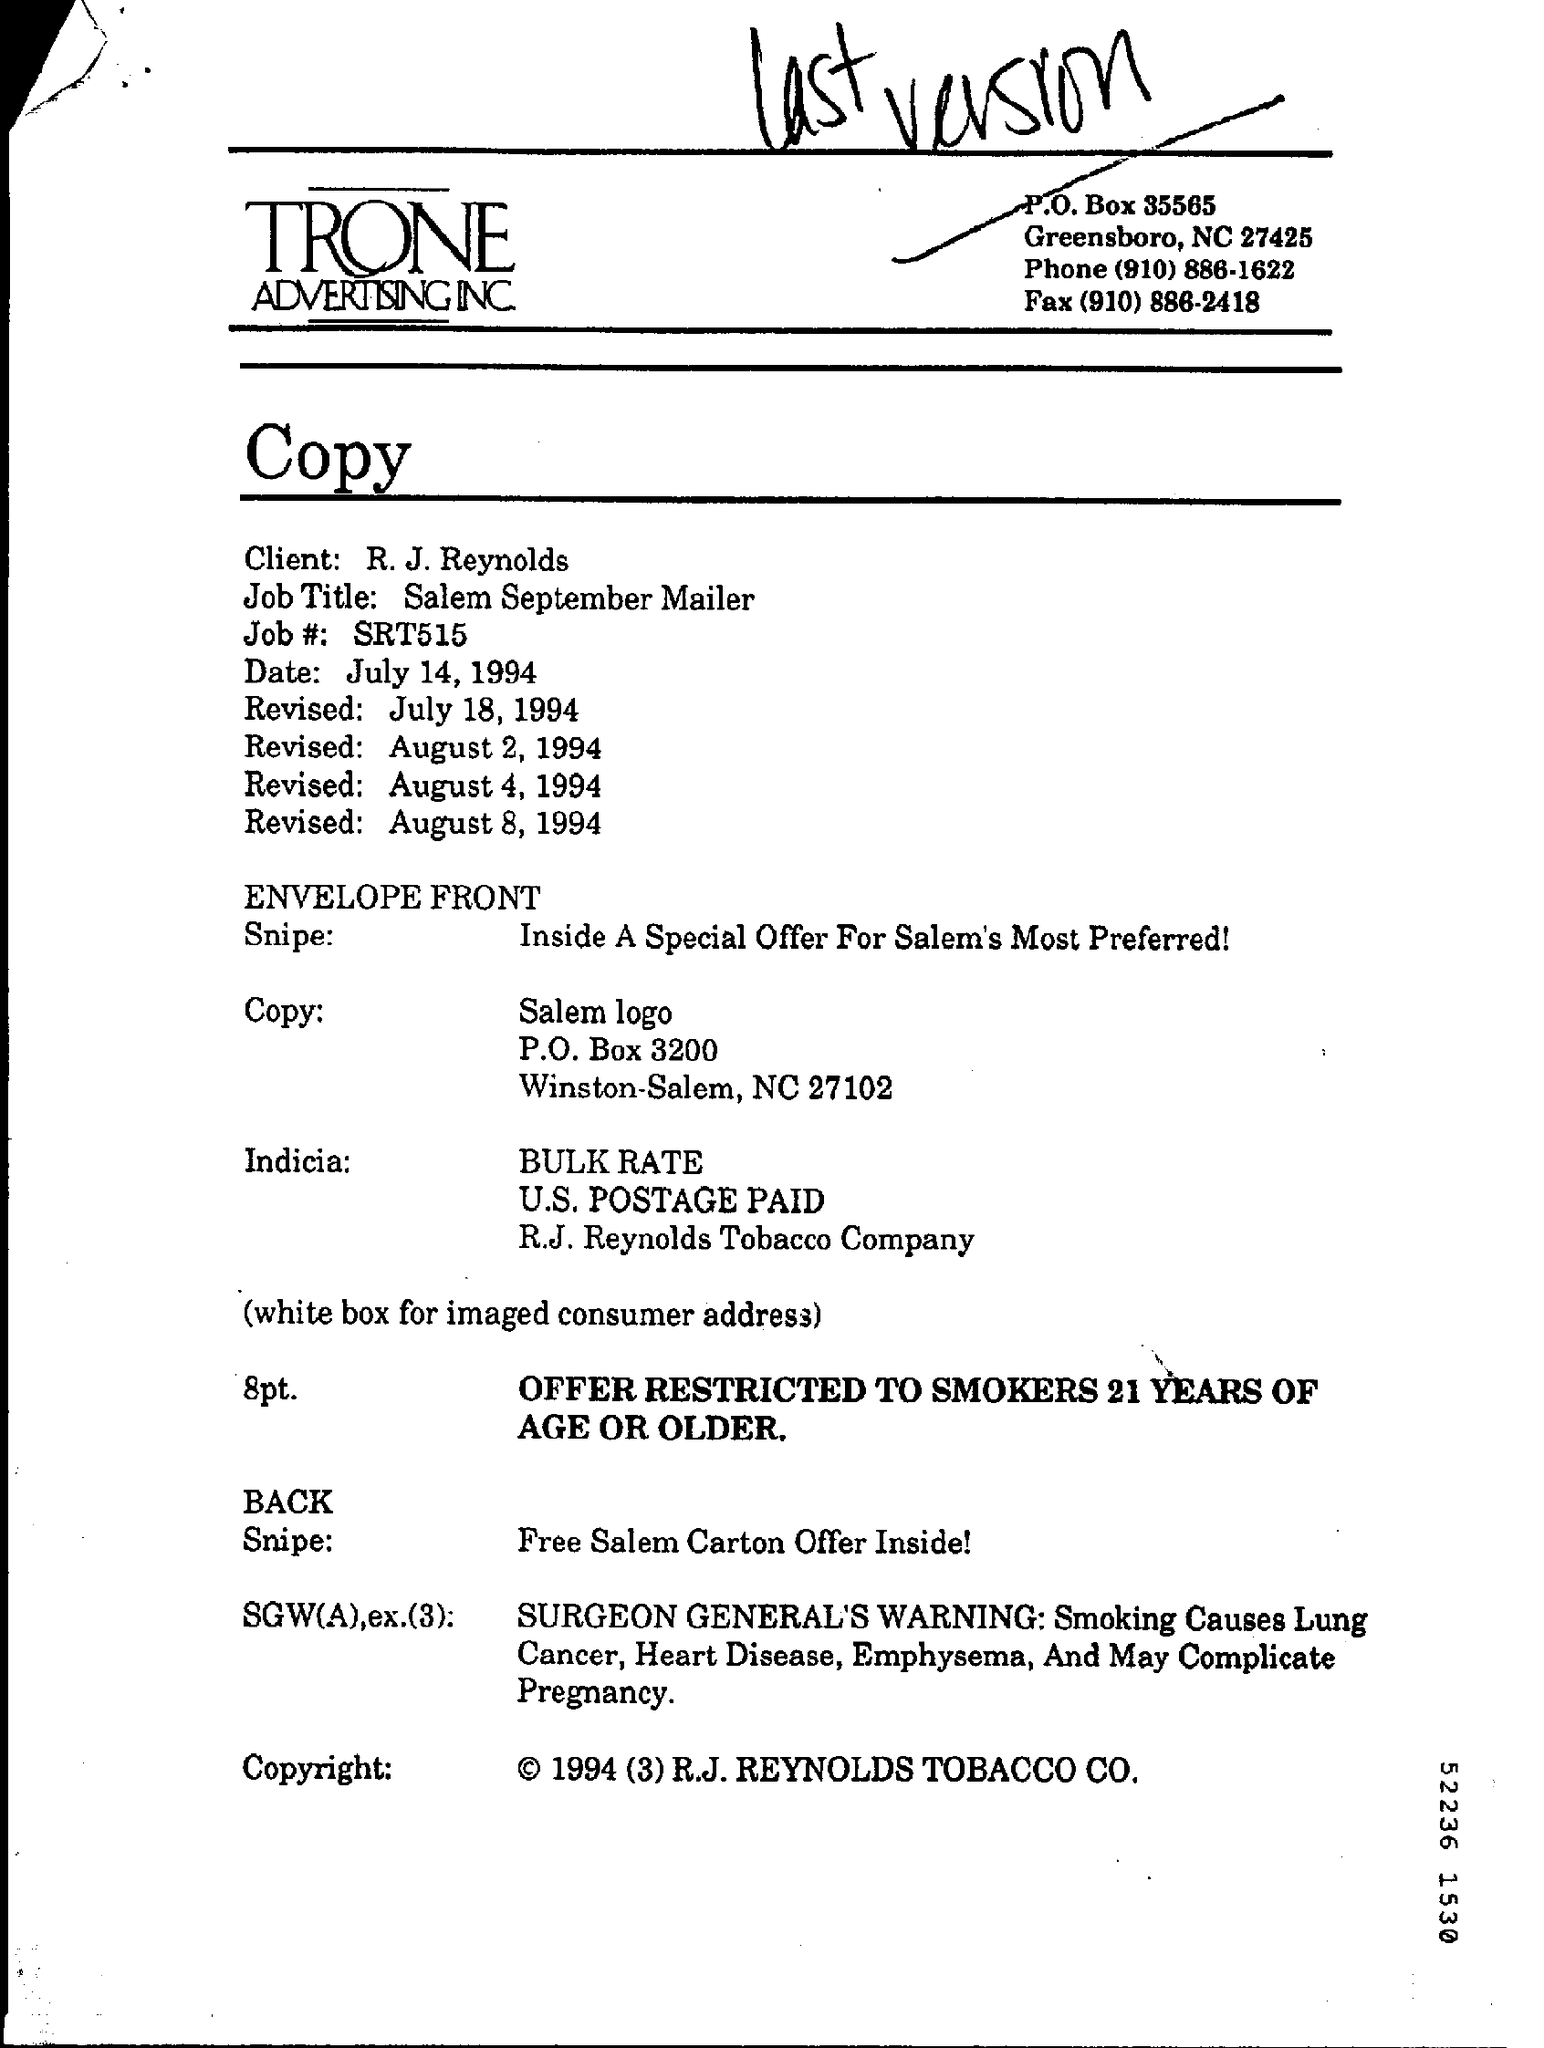Which company is mentioned in the letter head?
Offer a very short reply. TRONE ADVERTISING INC. Who is the client as per the document?
Your response must be concise. R. J. Reynolds. What is the Job Title given in the document?
Provide a succinct answer. Salem September Mailer. What is the Job #(no)  given in the document?
Your answer should be compact. SRT515. 